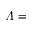Convert formula to latex. <formula><loc_0><loc_0><loc_500><loc_500>\varLambda =</formula> 